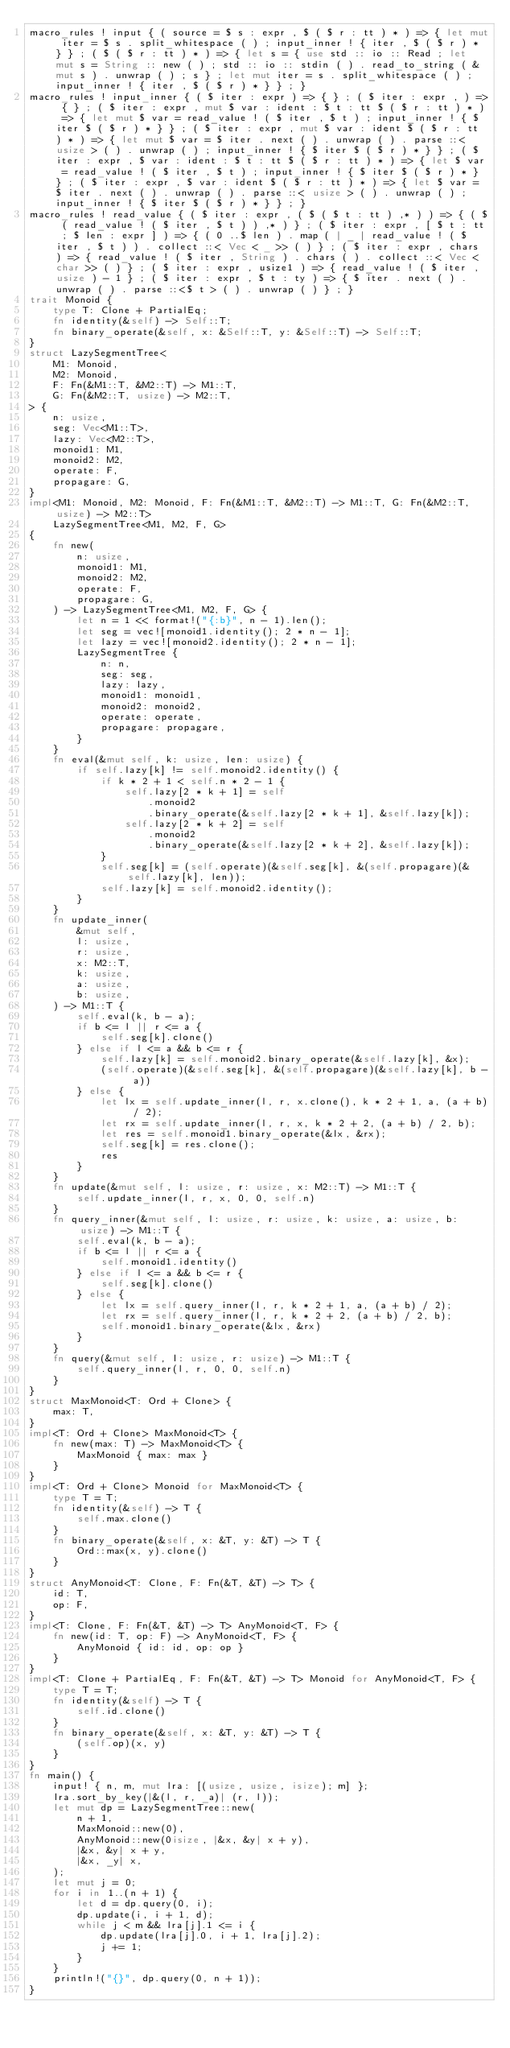<code> <loc_0><loc_0><loc_500><loc_500><_Rust_>macro_rules ! input { ( source = $ s : expr , $ ( $ r : tt ) * ) => { let mut iter = $ s . split_whitespace ( ) ; input_inner ! { iter , $ ( $ r ) * } } ; ( $ ( $ r : tt ) * ) => { let s = { use std :: io :: Read ; let mut s = String :: new ( ) ; std :: io :: stdin ( ) . read_to_string ( & mut s ) . unwrap ( ) ; s } ; let mut iter = s . split_whitespace ( ) ; input_inner ! { iter , $ ( $ r ) * } } ; }
macro_rules ! input_inner { ( $ iter : expr ) => { } ; ( $ iter : expr , ) => { } ; ( $ iter : expr , mut $ var : ident : $ t : tt $ ( $ r : tt ) * ) => { let mut $ var = read_value ! ( $ iter , $ t ) ; input_inner ! { $ iter $ ( $ r ) * } } ; ( $ iter : expr , mut $ var : ident $ ( $ r : tt ) * ) => { let mut $ var = $ iter . next ( ) . unwrap ( ) . parse ::< usize > ( ) . unwrap ( ) ; input_inner ! { $ iter $ ( $ r ) * } } ; ( $ iter : expr , $ var : ident : $ t : tt $ ( $ r : tt ) * ) => { let $ var = read_value ! ( $ iter , $ t ) ; input_inner ! { $ iter $ ( $ r ) * } } ; ( $ iter : expr , $ var : ident $ ( $ r : tt ) * ) => { let $ var = $ iter . next ( ) . unwrap ( ) . parse ::< usize > ( ) . unwrap ( ) ; input_inner ! { $ iter $ ( $ r ) * } } ; }
macro_rules ! read_value { ( $ iter : expr , ( $ ( $ t : tt ) ,* ) ) => { ( $ ( read_value ! ( $ iter , $ t ) ) ,* ) } ; ( $ iter : expr , [ $ t : tt ; $ len : expr ] ) => { ( 0 ..$ len ) . map ( | _ | read_value ! ( $ iter , $ t ) ) . collect ::< Vec < _ >> ( ) } ; ( $ iter : expr , chars ) => { read_value ! ( $ iter , String ) . chars ( ) . collect ::< Vec < char >> ( ) } ; ( $ iter : expr , usize1 ) => { read_value ! ( $ iter , usize ) - 1 } ; ( $ iter : expr , $ t : ty ) => { $ iter . next ( ) . unwrap ( ) . parse ::<$ t > ( ) . unwrap ( ) } ; }
trait Monoid {
    type T: Clone + PartialEq;
    fn identity(&self) -> Self::T;
    fn binary_operate(&self, x: &Self::T, y: &Self::T) -> Self::T;
}
struct LazySegmentTree<
    M1: Monoid,
    M2: Monoid,
    F: Fn(&M1::T, &M2::T) -> M1::T,
    G: Fn(&M2::T, usize) -> M2::T,
> {
    n: usize,
    seg: Vec<M1::T>,
    lazy: Vec<M2::T>,
    monoid1: M1,
    monoid2: M2,
    operate: F,
    propagare: G,
}
impl<M1: Monoid, M2: Monoid, F: Fn(&M1::T, &M2::T) -> M1::T, G: Fn(&M2::T, usize) -> M2::T>
    LazySegmentTree<M1, M2, F, G>
{
    fn new(
        n: usize,
        monoid1: M1,
        monoid2: M2,
        operate: F,
        propagare: G,
    ) -> LazySegmentTree<M1, M2, F, G> {
        let n = 1 << format!("{:b}", n - 1).len();
        let seg = vec![monoid1.identity(); 2 * n - 1];
        let lazy = vec![monoid2.identity(); 2 * n - 1];
        LazySegmentTree {
            n: n,
            seg: seg,
            lazy: lazy,
            monoid1: monoid1,
            monoid2: monoid2,
            operate: operate,
            propagare: propagare,
        }
    }
    fn eval(&mut self, k: usize, len: usize) {
        if self.lazy[k] != self.monoid2.identity() {
            if k * 2 + 1 < self.n * 2 - 1 {
                self.lazy[2 * k + 1] = self
                    .monoid2
                    .binary_operate(&self.lazy[2 * k + 1], &self.lazy[k]);
                self.lazy[2 * k + 2] = self
                    .monoid2
                    .binary_operate(&self.lazy[2 * k + 2], &self.lazy[k]);
            }
            self.seg[k] = (self.operate)(&self.seg[k], &(self.propagare)(&self.lazy[k], len));
            self.lazy[k] = self.monoid2.identity();
        }
    }
    fn update_inner(
        &mut self,
        l: usize,
        r: usize,
        x: M2::T,
        k: usize,
        a: usize,
        b: usize,
    ) -> M1::T {
        self.eval(k, b - a);
        if b <= l || r <= a {
            self.seg[k].clone()
        } else if l <= a && b <= r {
            self.lazy[k] = self.monoid2.binary_operate(&self.lazy[k], &x);
            (self.operate)(&self.seg[k], &(self.propagare)(&self.lazy[k], b - a))
        } else {
            let lx = self.update_inner(l, r, x.clone(), k * 2 + 1, a, (a + b) / 2);
            let rx = self.update_inner(l, r, x, k * 2 + 2, (a + b) / 2, b);
            let res = self.monoid1.binary_operate(&lx, &rx);
            self.seg[k] = res.clone();
            res
        }
    }
    fn update(&mut self, l: usize, r: usize, x: M2::T) -> M1::T {
        self.update_inner(l, r, x, 0, 0, self.n)
    }
    fn query_inner(&mut self, l: usize, r: usize, k: usize, a: usize, b: usize) -> M1::T {
        self.eval(k, b - a);
        if b <= l || r <= a {
            self.monoid1.identity()
        } else if l <= a && b <= r {
            self.seg[k].clone()
        } else {
            let lx = self.query_inner(l, r, k * 2 + 1, a, (a + b) / 2);
            let rx = self.query_inner(l, r, k * 2 + 2, (a + b) / 2, b);
            self.monoid1.binary_operate(&lx, &rx)
        }
    }
    fn query(&mut self, l: usize, r: usize) -> M1::T {
        self.query_inner(l, r, 0, 0, self.n)
    }
}
struct MaxMonoid<T: Ord + Clone> {
    max: T,
}
impl<T: Ord + Clone> MaxMonoid<T> {
    fn new(max: T) -> MaxMonoid<T> {
        MaxMonoid { max: max }
    }
}
impl<T: Ord + Clone> Monoid for MaxMonoid<T> {
    type T = T;
    fn identity(&self) -> T {
        self.max.clone()
    }
    fn binary_operate(&self, x: &T, y: &T) -> T {
        Ord::max(x, y).clone()
    }
}
struct AnyMonoid<T: Clone, F: Fn(&T, &T) -> T> {
    id: T,
    op: F,
}
impl<T: Clone, F: Fn(&T, &T) -> T> AnyMonoid<T, F> {
    fn new(id: T, op: F) -> AnyMonoid<T, F> {
        AnyMonoid { id: id, op: op }
    }
}
impl<T: Clone + PartialEq, F: Fn(&T, &T) -> T> Monoid for AnyMonoid<T, F> {
    type T = T;
    fn identity(&self) -> T {
        self.id.clone()
    }
    fn binary_operate(&self, x: &T, y: &T) -> T {
        (self.op)(x, y)
    }
}
fn main() {
    input! { n, m, mut lra: [(usize, usize, isize); m] };
    lra.sort_by_key(|&(l, r, _a)| (r, l));
    let mut dp = LazySegmentTree::new(
        n + 1,
        MaxMonoid::new(0),
        AnyMonoid::new(0isize, |&x, &y| x + y),
        |&x, &y| x + y,
        |&x, _y| x,
    );
    let mut j = 0;
    for i in 1..(n + 1) {
        let d = dp.query(0, i);
        dp.update(i, i + 1, d);
        while j < m && lra[j].1 <= i {
            dp.update(lra[j].0, i + 1, lra[j].2);
            j += 1;
        }
    }
    println!("{}", dp.query(0, n + 1));
}
</code> 